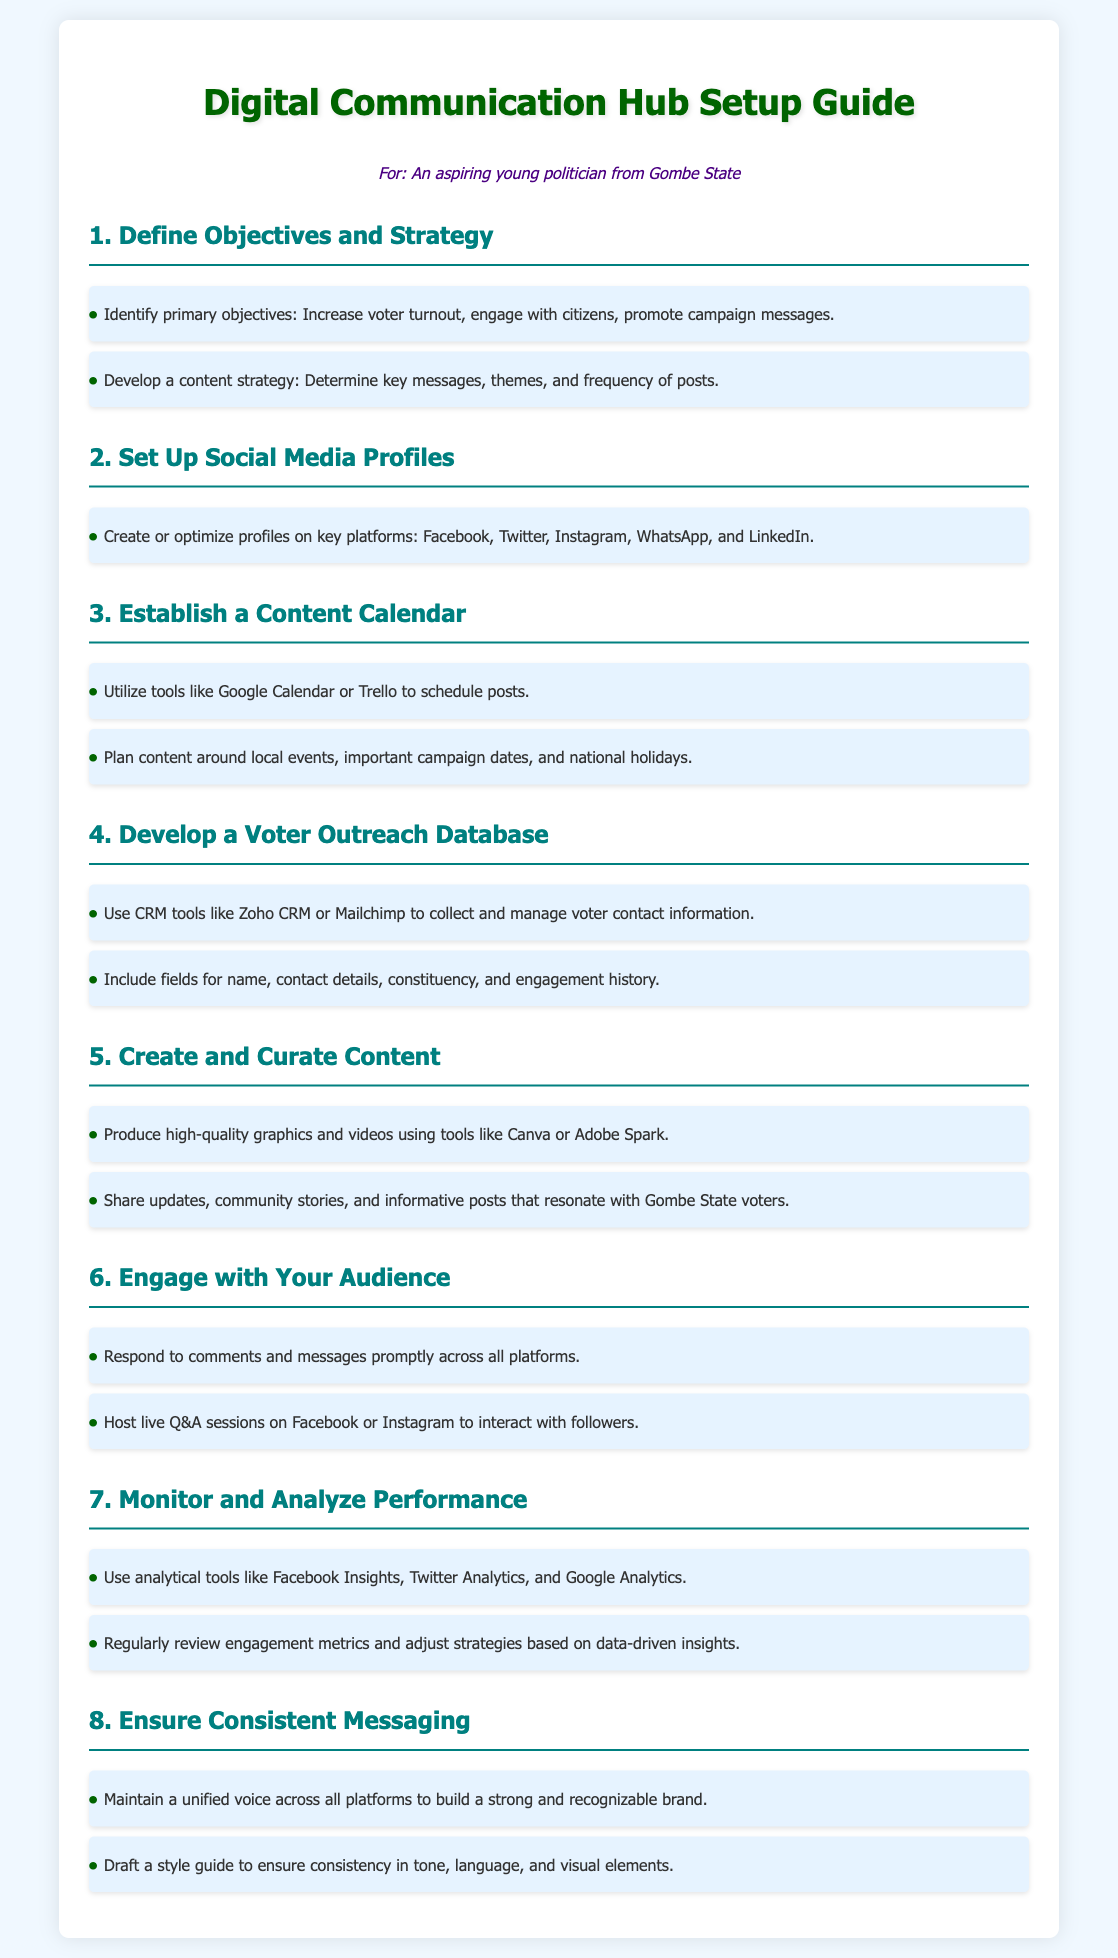What is the main goal of the digital communication hub? The main goal is to increase voter turnout, engage with citizens, and promote campaign messages.
Answer: Increase voter turnout, engage with citizens, promote campaign messages Which tools are suggested for scheduling posts? The document recommends using tools like Google Calendar or Trello for scheduling posts.
Answer: Google Calendar or Trello How many key social media platforms should be set up? The document specifies creating profiles on key platforms, indicating five main platforms to focus on.
Answer: Five What is required to develop a voter outreach database? The development of a voter outreach database requires the use of CRM tools to collect and manage voter contact information.
Answer: CRM tools What metric should be regularly reviewed for performance analysis? The document states that engagement metrics should be regularly reviewed to gain insights.
Answer: Engagement metrics What type of sessions are suggested to engage with the audience? The document suggests hosting live Q&A sessions to interact with followers.
Answer: Live Q&A sessions What does maintaining a unified voice help build? A unified voice helps build a strong and recognizable brand across platforms.
Answer: Strong and recognizable brand Which design tools are recommended for creating content? The document mentions using tools like Canva or Adobe Spark to produce high-quality graphics and videos.
Answer: Canva or Adobe Spark 